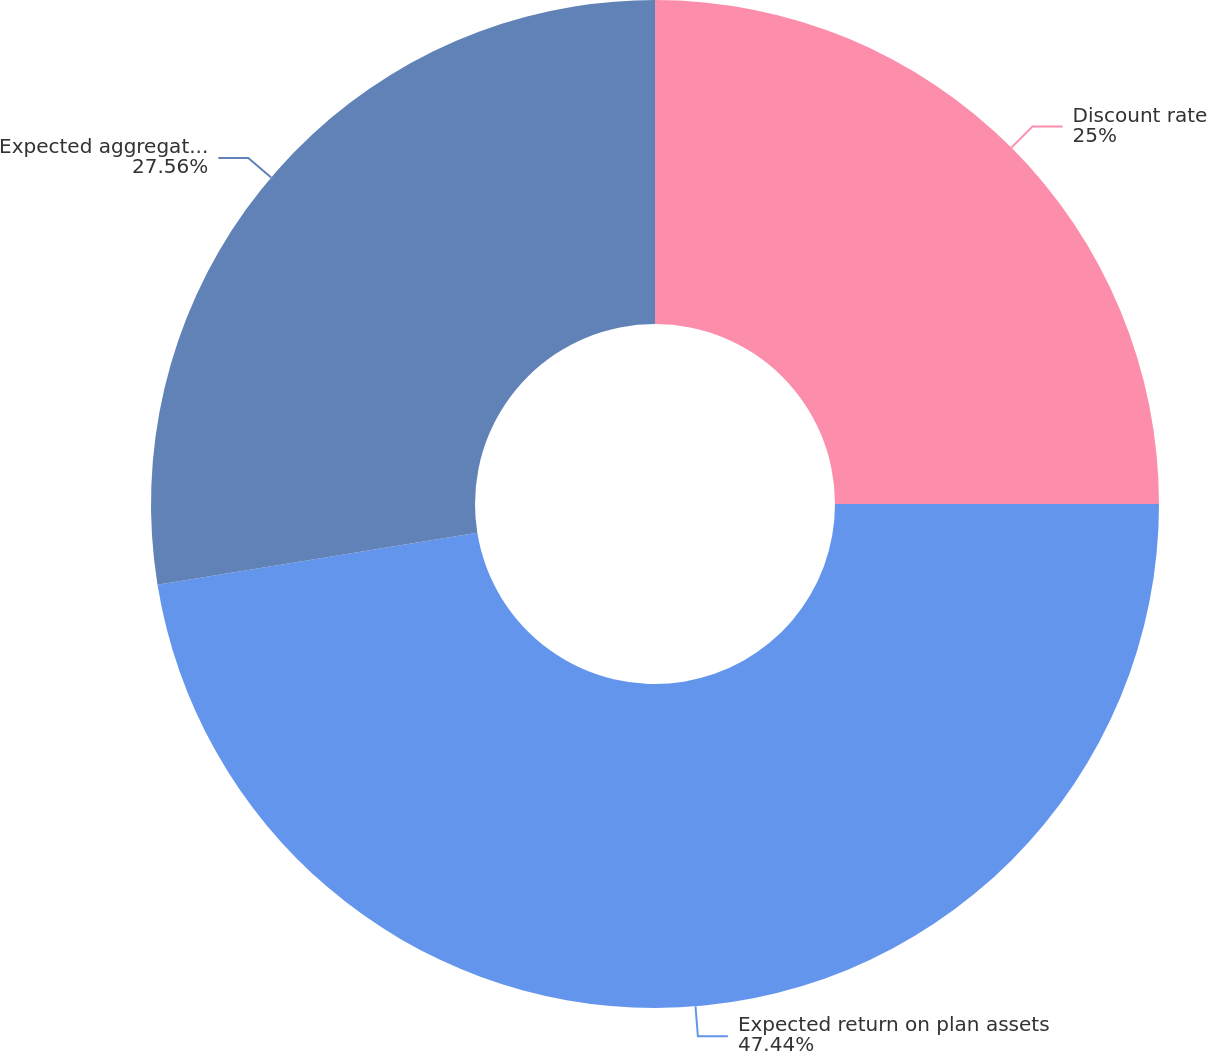<chart> <loc_0><loc_0><loc_500><loc_500><pie_chart><fcel>Discount rate<fcel>Expected return on plan assets<fcel>Expected aggregate average<nl><fcel>25.0%<fcel>47.44%<fcel>27.56%<nl></chart> 